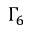<formula> <loc_0><loc_0><loc_500><loc_500>\Gamma _ { 6 }</formula> 